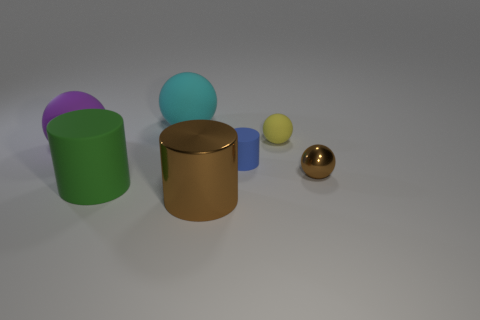Subtract all yellow balls. How many balls are left? 3 Subtract 1 balls. How many balls are left? 3 Subtract all tiny yellow spheres. How many spheres are left? 3 Subtract all red spheres. Subtract all blue blocks. How many spheres are left? 4 Add 1 brown matte cylinders. How many objects exist? 8 Subtract all balls. How many objects are left? 3 Subtract 0 brown blocks. How many objects are left? 7 Subtract all green rubber objects. Subtract all metal cylinders. How many objects are left? 5 Add 2 spheres. How many spheres are left? 6 Add 3 large matte balls. How many large matte balls exist? 5 